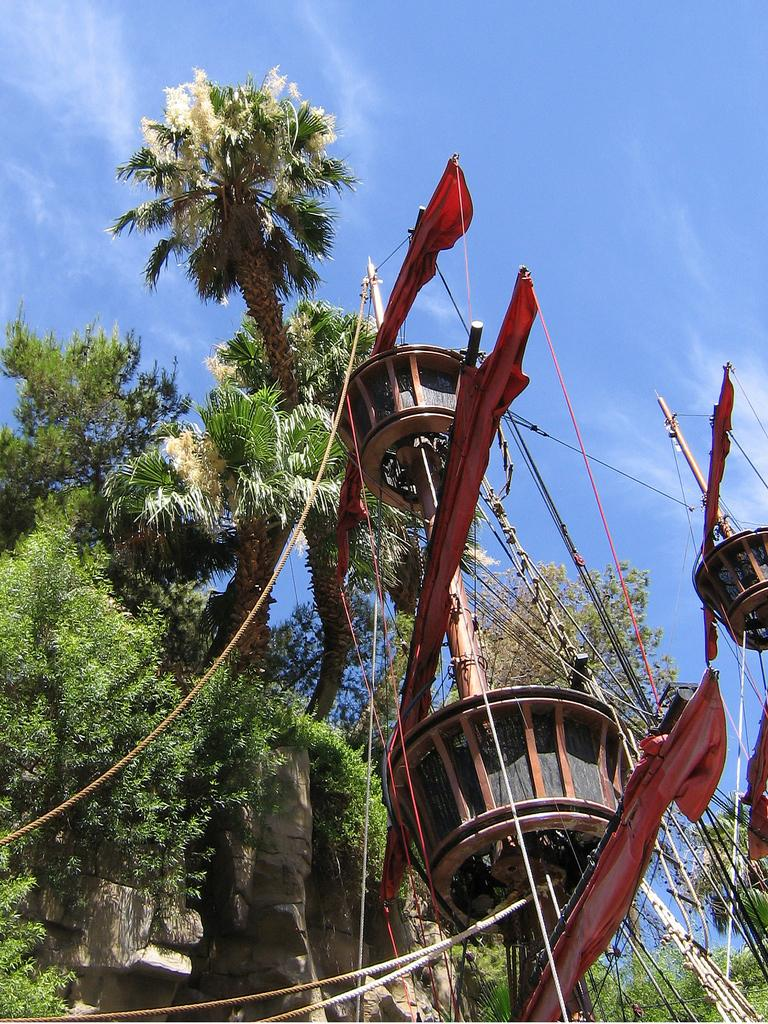What type of ship is in the image? There is a pirate ship in the image. What color is the pirate ship? The pirate ship is red. What are some features of the pirate ship? There are ropes associated with the pirate ship. What can be seen in the background of the image? There are many trees and clouds in the background of the image. What is the color of the sky in the image? The sky is white in the image. What time is displayed on the clock in the image? There is no clock present in the image. How does the pirate ship make the baby cry in the image? There is no baby or crying in the image; it features a pirate ship and its surroundings. 